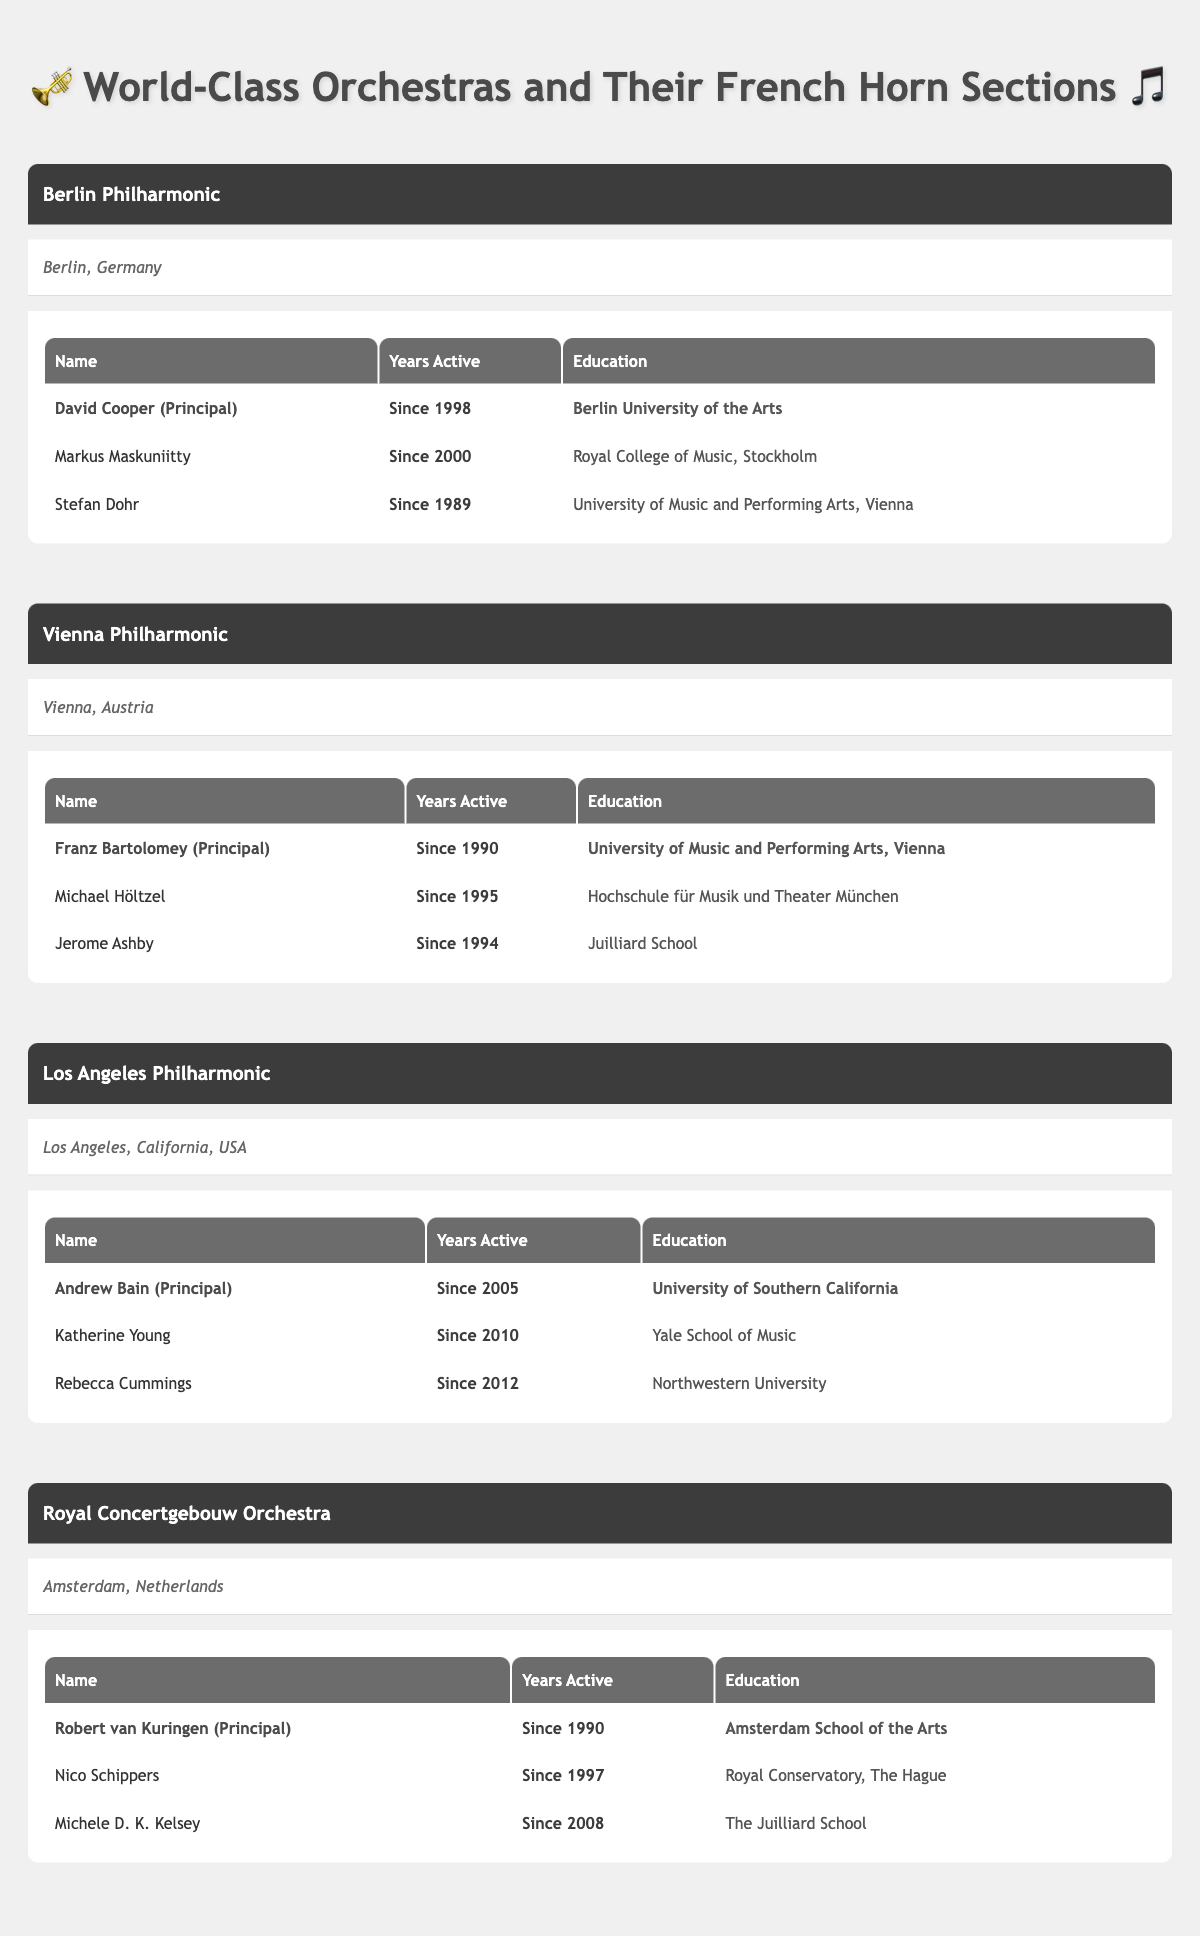What is the name of the principal horn player in the Berlin Philharmonic? Looking at the table for the Berlin Philharmonic, the principal horn player is David Cooper, as indicated in the French horn section.
Answer: David Cooper How many years has Stefan Dohr been active as a horn player? From the Berlin Philharmonic section, it states that Stefan Dohr has been active since 1989.
Answer: Since 1989 Which orchestra has a principal horn player who graduated from the Juilliard School? Checking the section for each orchestra, the Royal Concertgebouw Orchestra has a section member named Michele D. K. Kelsey who graduated from the Juilliard School.
Answer: Royal Concertgebouw Orchestra Is Franz Bartolomey still active as the principal horn player in the Vienna Philharmonic? The table states that Franz Bartolomey has been active since 1990, which implies he is still active unless specified otherwise. Since no end date is provided, it is reasonable to conclude he is still active.
Answer: Yes Which orchestra has the most recent active members based on the provided years? Looking at the years active of the section members: the most recent members in the Los Angeles Philharmonic are Katherine Young (2010) and Rebecca Cummings (2012). In comparison, all other orchestras have earlier active dates. This means the Los Angeles Philharmonic has the most recent active members.
Answer: Los Angeles Philharmonic What is the average number of years active for all principal horn players in the table? The principal players are David Cooper, Franz Bartolomey, Andrew Bain, and Robert van Kuringen with years active 1998, 1990, 2005, and 1990 respectively. Summing these up gives (2023-1998) + (2023-1990) + (2023-2005) + (2023-1990) = 25 + 33 + 18 + 33 = 109. There are 4 principal players, so the average is 109/4 = 27.25.
Answer: 27.25 Who has been active longer, the principal horn player of the Royal Concertgebouw Orchestra or the Los Angeles Philharmonic? Robert van Kuringen is the principal horn player of the Royal Concertgebouw Orchestra since 1990, while Andrew Bain, the principal of the Los Angeles Philharmonic, has been active since 2005. Since 1990 is earlier than 2005, Van Kuringen has been active longer.
Answer: Robert van Kuringen Which orchestra has the least number of section members based on the data? Looking at the number of section members for each orchestra, the Berlin Philharmonic and Vienna Philharmonic each have two members besides their principal player. The Royal Concertgebouw Orchestra also has two, while the Los Angeles Philharmonic has three members. Therefore, all but the Los Angeles Philharmonic have the least number of section members, which is two.
Answer: Berlin Philharmonic, Vienna Philharmonic, Royal Concertgebouw Orchestra 